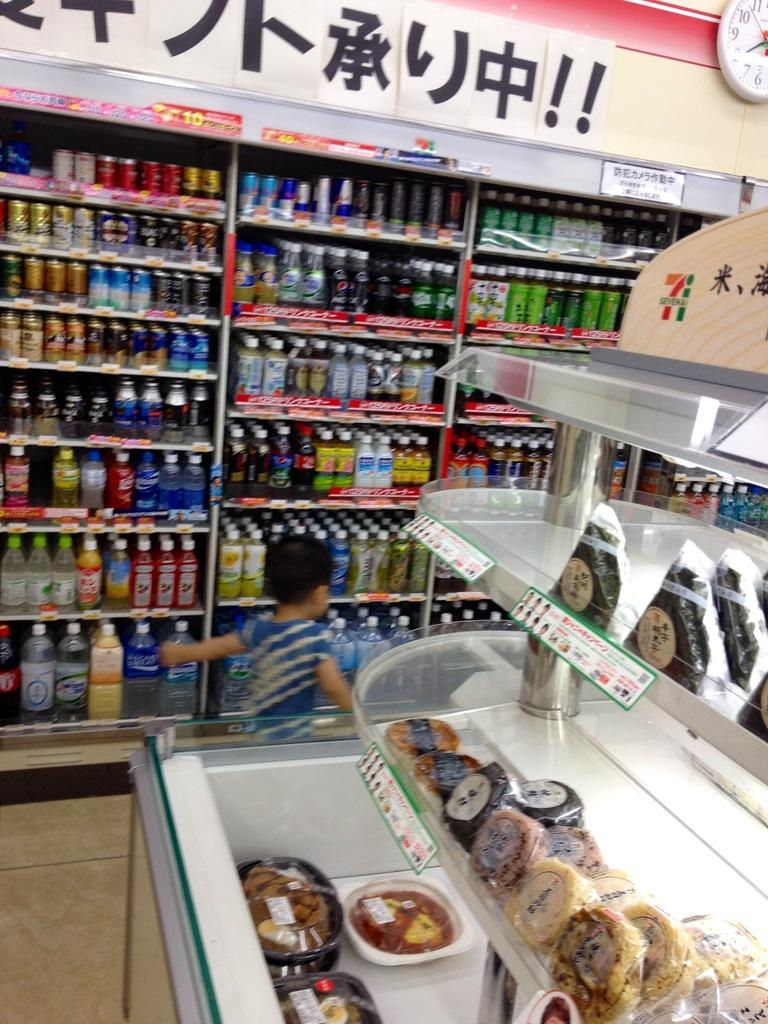<image>
Describe the image concisely. Boy running in a store near a stand with the number 7 on it. 